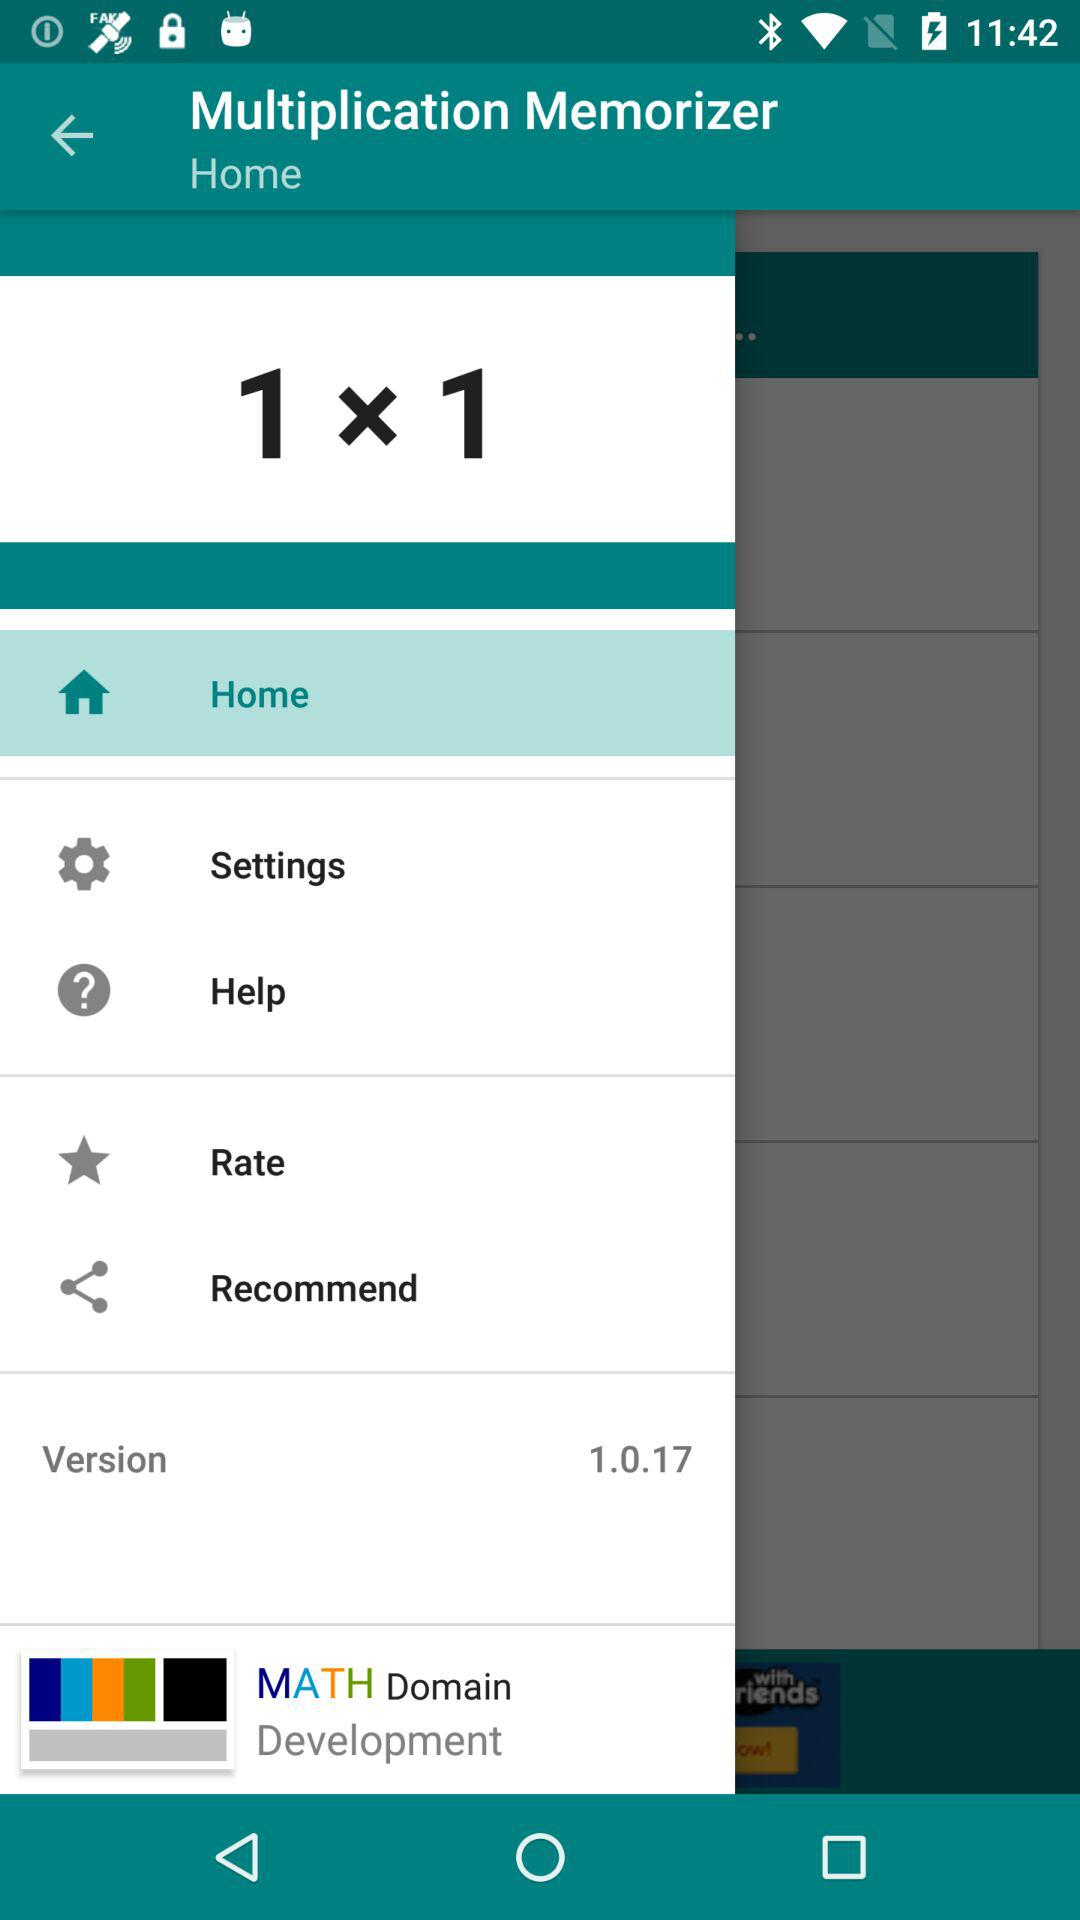Who developed the application? The application was developed by "MATH Domain Development". 